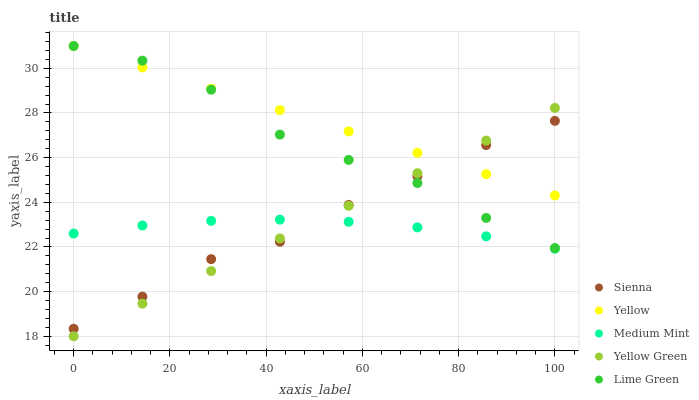Does Medium Mint have the minimum area under the curve?
Answer yes or no. Yes. Does Yellow have the maximum area under the curve?
Answer yes or no. Yes. Does Lime Green have the minimum area under the curve?
Answer yes or no. No. Does Lime Green have the maximum area under the curve?
Answer yes or no. No. Is Yellow Green the smoothest?
Answer yes or no. Yes. Is Lime Green the roughest?
Answer yes or no. Yes. Is Medium Mint the smoothest?
Answer yes or no. No. Is Medium Mint the roughest?
Answer yes or no. No. Does Yellow Green have the lowest value?
Answer yes or no. Yes. Does Medium Mint have the lowest value?
Answer yes or no. No. Does Yellow have the highest value?
Answer yes or no. Yes. Does Medium Mint have the highest value?
Answer yes or no. No. Is Medium Mint less than Lime Green?
Answer yes or no. Yes. Is Lime Green greater than Medium Mint?
Answer yes or no. Yes. Does Sienna intersect Yellow Green?
Answer yes or no. Yes. Is Sienna less than Yellow Green?
Answer yes or no. No. Is Sienna greater than Yellow Green?
Answer yes or no. No. Does Medium Mint intersect Lime Green?
Answer yes or no. No. 